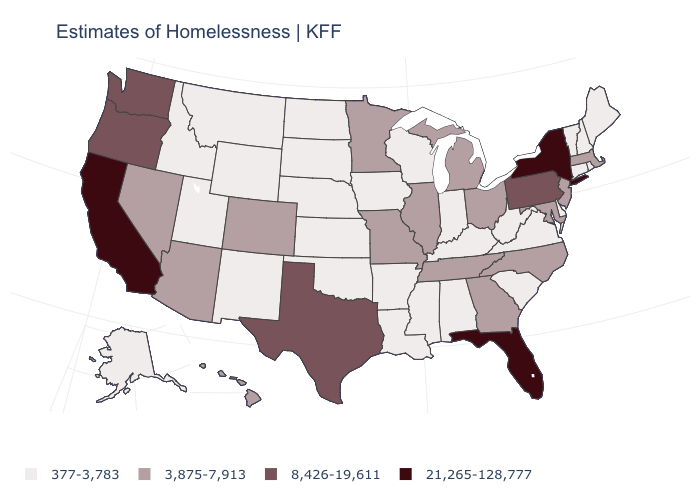Name the states that have a value in the range 377-3,783?
Write a very short answer. Alabama, Alaska, Arkansas, Connecticut, Delaware, Idaho, Indiana, Iowa, Kansas, Kentucky, Louisiana, Maine, Mississippi, Montana, Nebraska, New Hampshire, New Mexico, North Dakota, Oklahoma, Rhode Island, South Carolina, South Dakota, Utah, Vermont, Virginia, West Virginia, Wisconsin, Wyoming. What is the value of Illinois?
Answer briefly. 3,875-7,913. What is the highest value in the West ?
Concise answer only. 21,265-128,777. Which states have the highest value in the USA?
Answer briefly. California, Florida, New York. Name the states that have a value in the range 8,426-19,611?
Short answer required. Oregon, Pennsylvania, Texas, Washington. Does Ohio have the lowest value in the MidWest?
Keep it brief. No. Name the states that have a value in the range 377-3,783?
Answer briefly. Alabama, Alaska, Arkansas, Connecticut, Delaware, Idaho, Indiana, Iowa, Kansas, Kentucky, Louisiana, Maine, Mississippi, Montana, Nebraska, New Hampshire, New Mexico, North Dakota, Oklahoma, Rhode Island, South Carolina, South Dakota, Utah, Vermont, Virginia, West Virginia, Wisconsin, Wyoming. Name the states that have a value in the range 377-3,783?
Concise answer only. Alabama, Alaska, Arkansas, Connecticut, Delaware, Idaho, Indiana, Iowa, Kansas, Kentucky, Louisiana, Maine, Mississippi, Montana, Nebraska, New Hampshire, New Mexico, North Dakota, Oklahoma, Rhode Island, South Carolina, South Dakota, Utah, Vermont, Virginia, West Virginia, Wisconsin, Wyoming. What is the value of Nebraska?
Answer briefly. 377-3,783. What is the value of Mississippi?
Keep it brief. 377-3,783. Does the map have missing data?
Short answer required. No. What is the lowest value in states that border Arizona?
Keep it brief. 377-3,783. Does New York have the highest value in the USA?
Answer briefly. Yes. What is the highest value in the USA?
Write a very short answer. 21,265-128,777. Does Washington have a higher value than Mississippi?
Short answer required. Yes. 